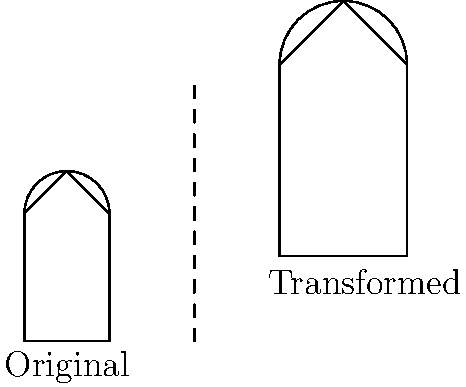You need to adjust your cupcake icon for different product box sizes. The original icon is 1 cm wide and 2 cm tall. For a larger box, you scale the icon by a factor of 1.5 and then translate it 3 cm right and 1 cm up. What are the dimensions of the transformed cupcake icon, and where is its bottom-left corner located in relation to the original icon's position? Let's break this down step-by-step:

1. Original dimensions:
   Width = 1 cm
   Height = 2 cm

2. Scaling:
   Scale factor = 1.5
   New width = 1 cm × 1.5 = 1.5 cm
   New height = 2 cm × 1.5 = 3 cm

3. Translation:
   Right shift = 3 cm
   Upward shift = 1 cm

4. Final position of bottom-left corner:
   x-coordinate: 0 + 3 = 3 cm to the right
   y-coordinate: 0 + 1 = 1 cm up

Therefore, the transformed cupcake icon has dimensions of 1.5 cm × 3 cm, and its bottom-left corner is located 3 cm to the right and 1 cm up from the original position.
Answer: 1.5 cm × 3 cm; (3 cm, 1 cm) 